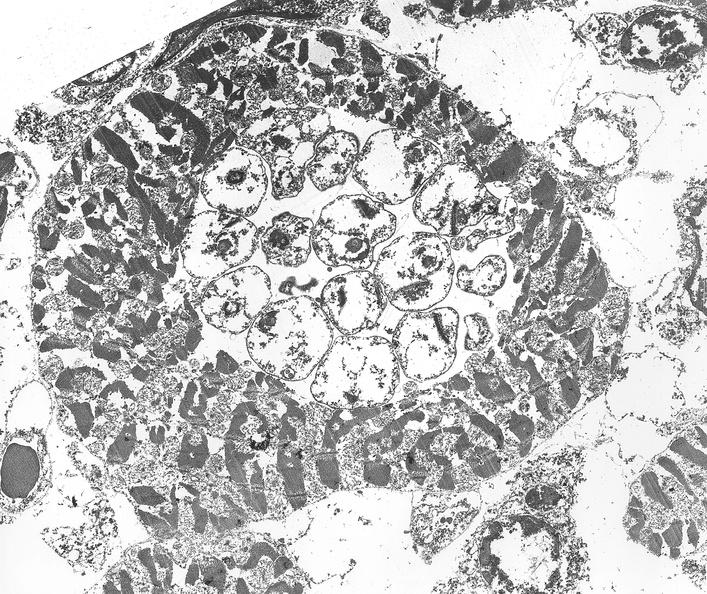where is this?
Answer the question using a single word or phrase. Heart 